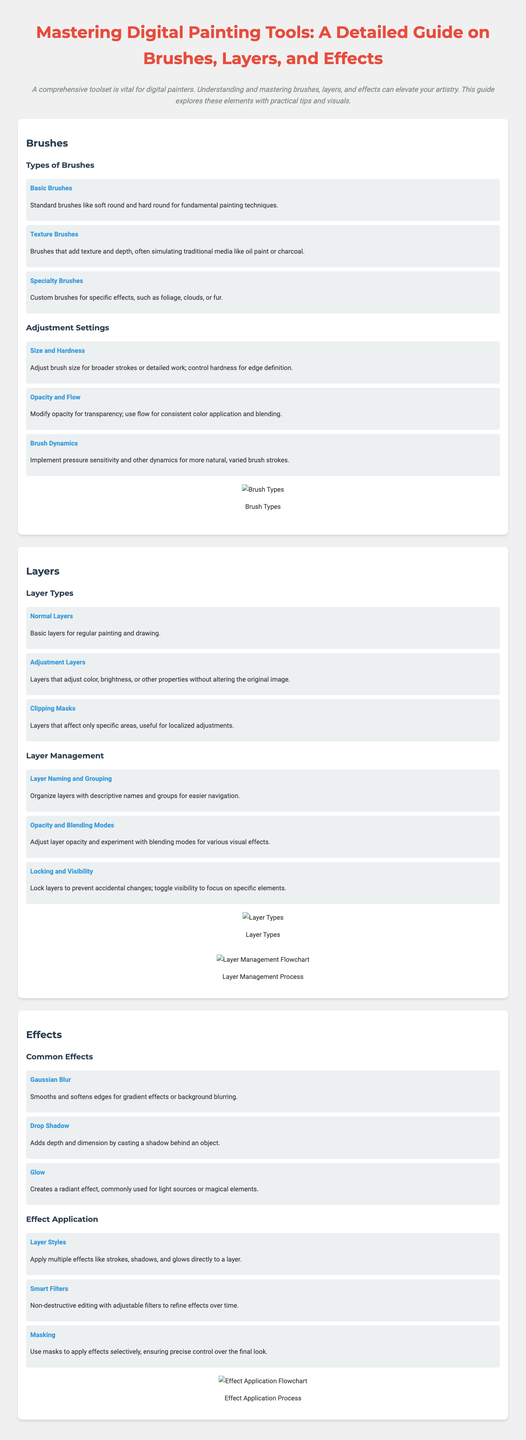what are the three main sections of the infographic? The infographic is divided into three main sections: Brushes, Layers, and Effects.
Answer: Brushes, Layers, Effects which brush type is used for fundamental painting techniques? Basic brushes like soft round and hard round are for fundamental painting techniques.
Answer: Basic Brushes what adjustment setting modifies the transparency of a brush? The adjustment setting that modifies the transparency of a brush is Opacity.
Answer: Opacity what type of layer allows adjustments without altering the original image? Adjustment layers allow adjustments without altering the original image.
Answer: Adjustment Layers what effect smooths and softens edges in digital painting? Gaussian Blur is the effect that smooths and softens edges.
Answer: Gaussian Blur what are the two components involved in layer management? Layer management involves Layer Naming and Grouping, and Opacity and Blending Modes.
Answer: Layer Naming and Grouping, Opacity and Blending Modes which technique is used to apply multiple effects directly to a layer? Layer Styles is the technique used to apply multiple effects directly to a layer.
Answer: Layer Styles what is a benefit of using Smart Filters? Smart Filters enable non-destructive editing with adjustable filters.
Answer: Non-destructive editing what does a Clipping Mask do? Clipping Masks affect only specific areas.
Answer: Affects only specific areas 